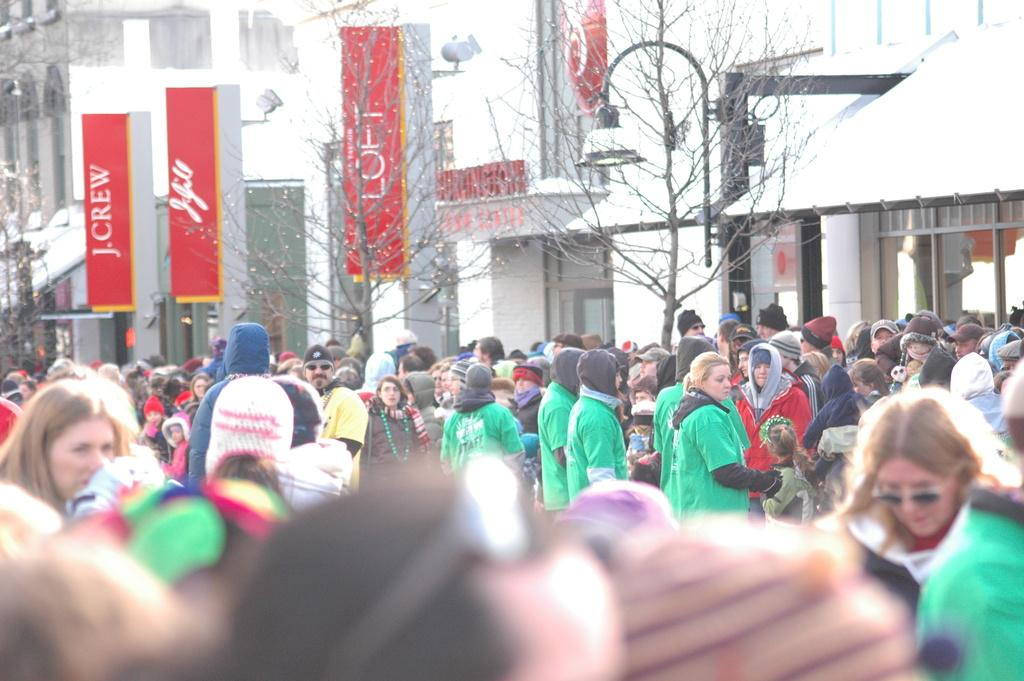What is the main subject in the middle of the image? There is a group of people in the middle of the image. What can be seen in the background of the image? There are trees, boards, lights, and buildings in the background of the image. What type of company is conducting a meeting in the cemetery in the image? There is no company or meeting in the cemetery in the image, as there are no cemeteries present. 